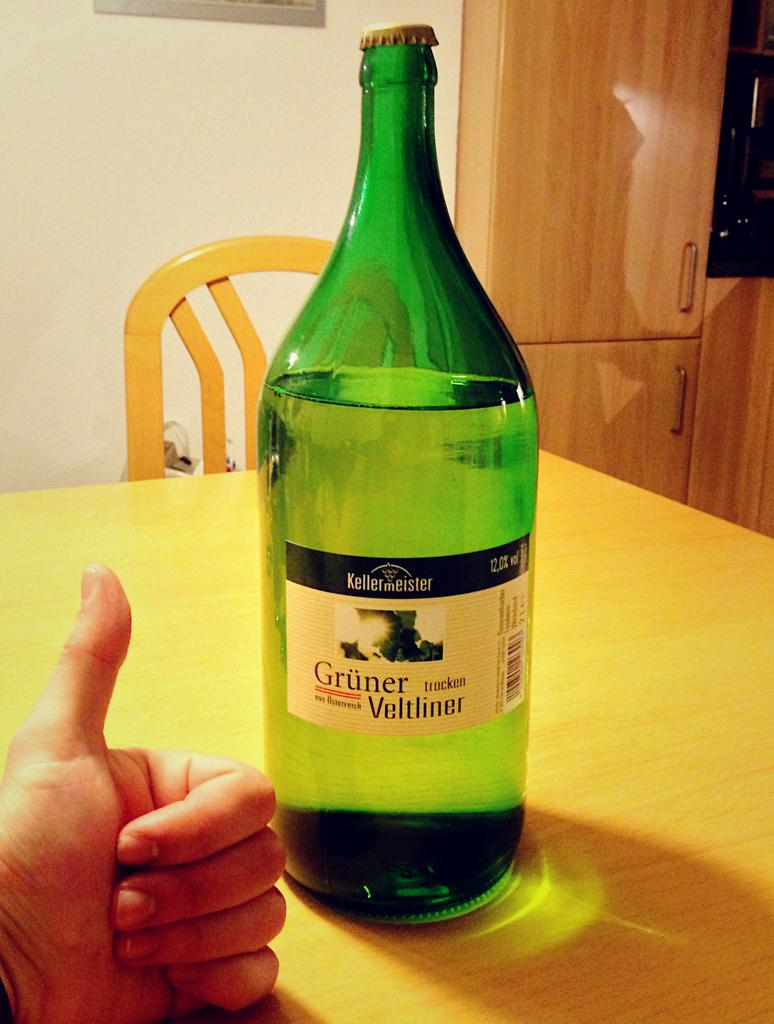<image>
Create a compact narrative representing the image presented. the word Gruner is on the green bottle 